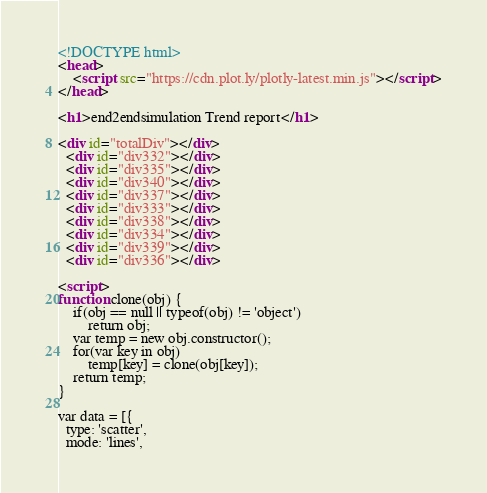<code> <loc_0><loc_0><loc_500><loc_500><_HTML_><!DOCTYPE html>
<head>
    <script src="https://cdn.plot.ly/plotly-latest.min.js"></script>
</head>

<h1>end2endsimulation Trend report</h1>

<div id="totalDiv"></div>
  <div id="div332"></div>
  <div id="div335"></div>
  <div id="div340"></div>
  <div id="div337"></div>
  <div id="div333"></div>
  <div id="div338"></div>
  <div id="div334"></div>
  <div id="div339"></div>
  <div id="div336"></div>

<script>
function clone(obj) {
    if(obj == null || typeof(obj) != 'object')
        return obj;
    var temp = new obj.constructor();
    for(var key in obj)
        temp[key] = clone(obj[key]);
    return temp;
}

var data = [{
  type: 'scatter',
  mode: 'lines',</code> 